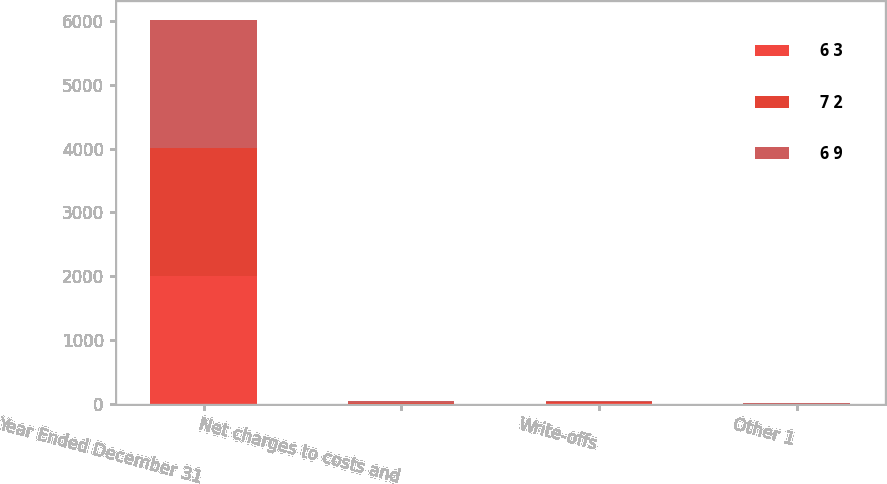Convert chart. <chart><loc_0><loc_0><loc_500><loc_500><stacked_bar_chart><ecel><fcel>Year Ended December 31<fcel>Net charges to costs and<fcel>Write-offs<fcel>Other 1<nl><fcel>6 3<fcel>2006<fcel>2<fcel>12<fcel>1<nl><fcel>7 2<fcel>2005<fcel>17<fcel>12<fcel>2<nl><fcel>6 9<fcel>2004<fcel>28<fcel>19<fcel>1<nl></chart> 